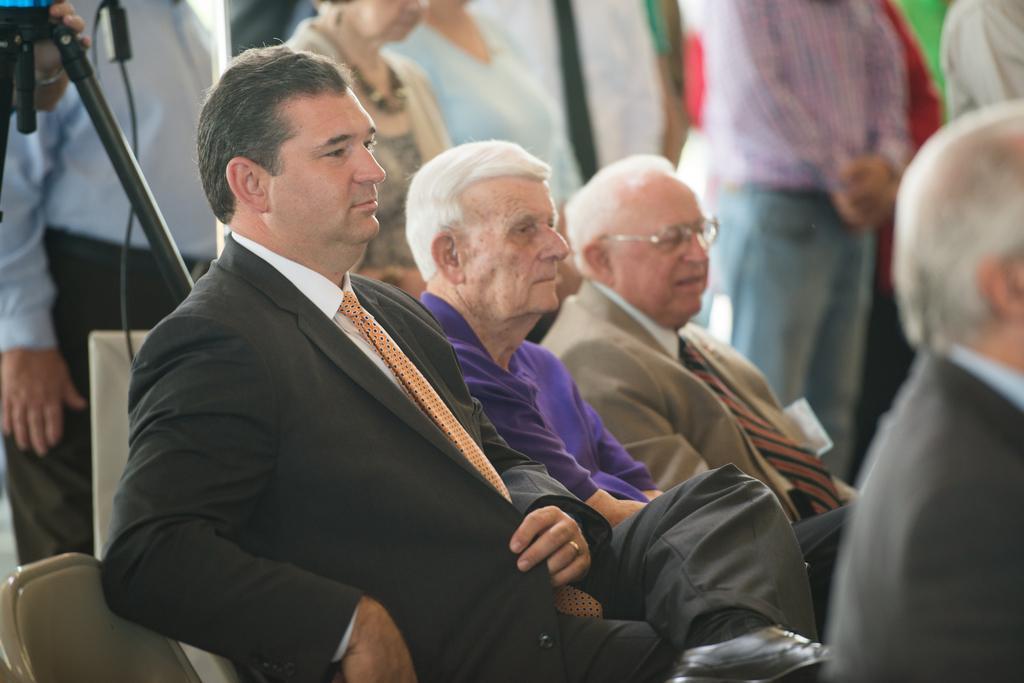Please provide a concise description of this image. In this image, we can see persons wearing clothes. There is a tripod and cable in the top left of the image. 